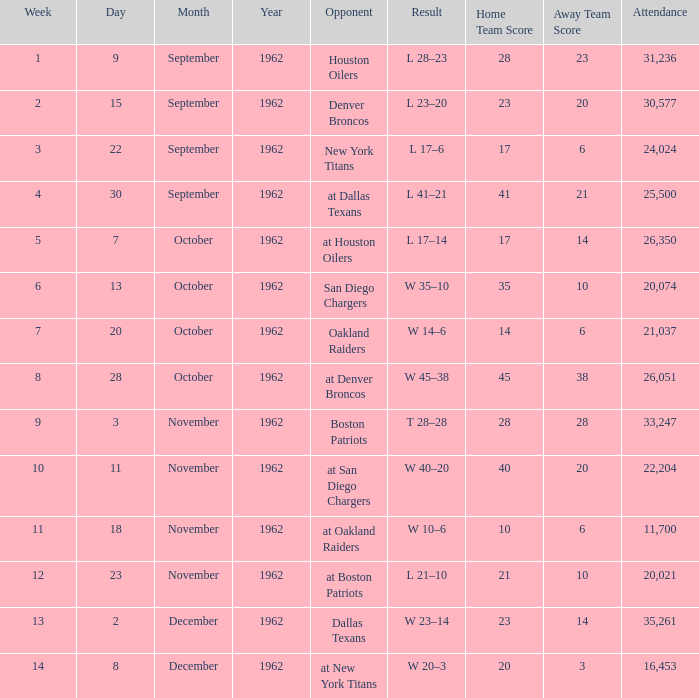What week was the attendance smaller than 22,204 on December 8, 1962? 14.0. 